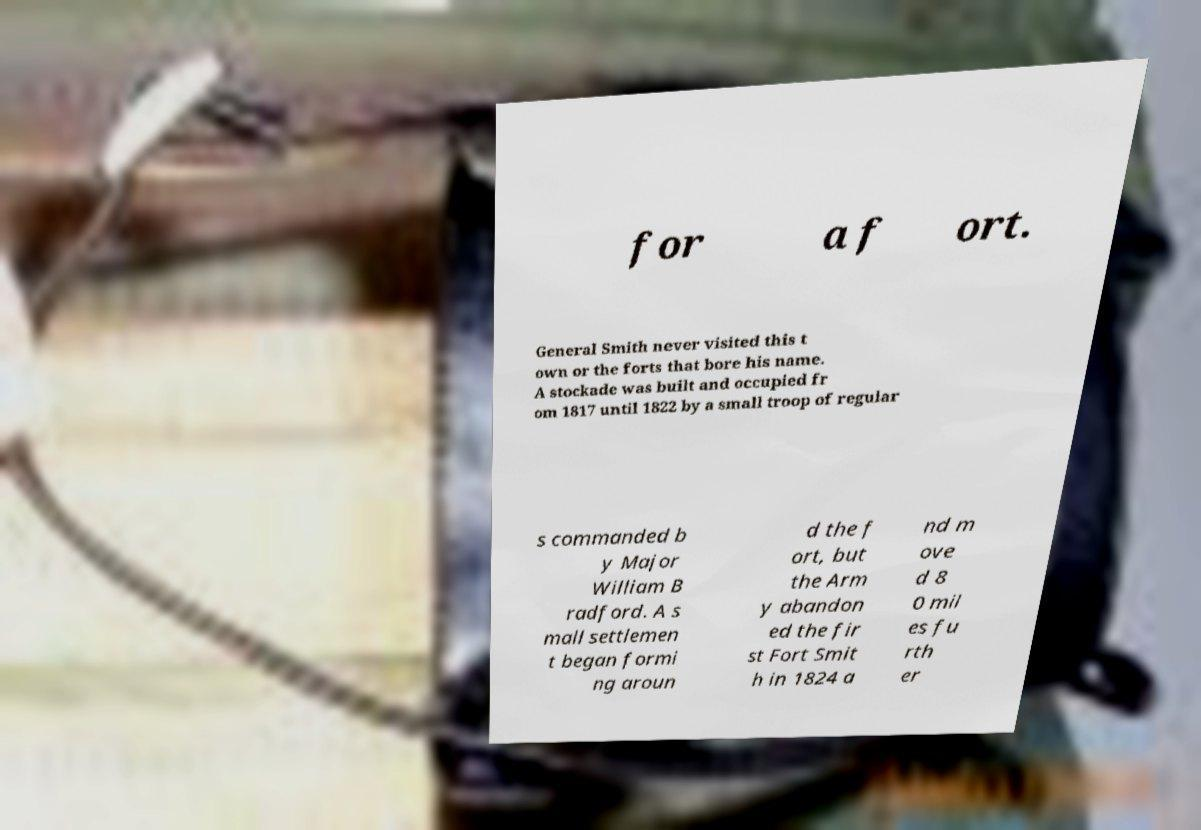I need the written content from this picture converted into text. Can you do that? for a f ort. General Smith never visited this t own or the forts that bore his name. A stockade was built and occupied fr om 1817 until 1822 by a small troop of regular s commanded b y Major William B radford. A s mall settlemen t began formi ng aroun d the f ort, but the Arm y abandon ed the fir st Fort Smit h in 1824 a nd m ove d 8 0 mil es fu rth er 